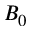<formula> <loc_0><loc_0><loc_500><loc_500>B _ { 0 }</formula> 